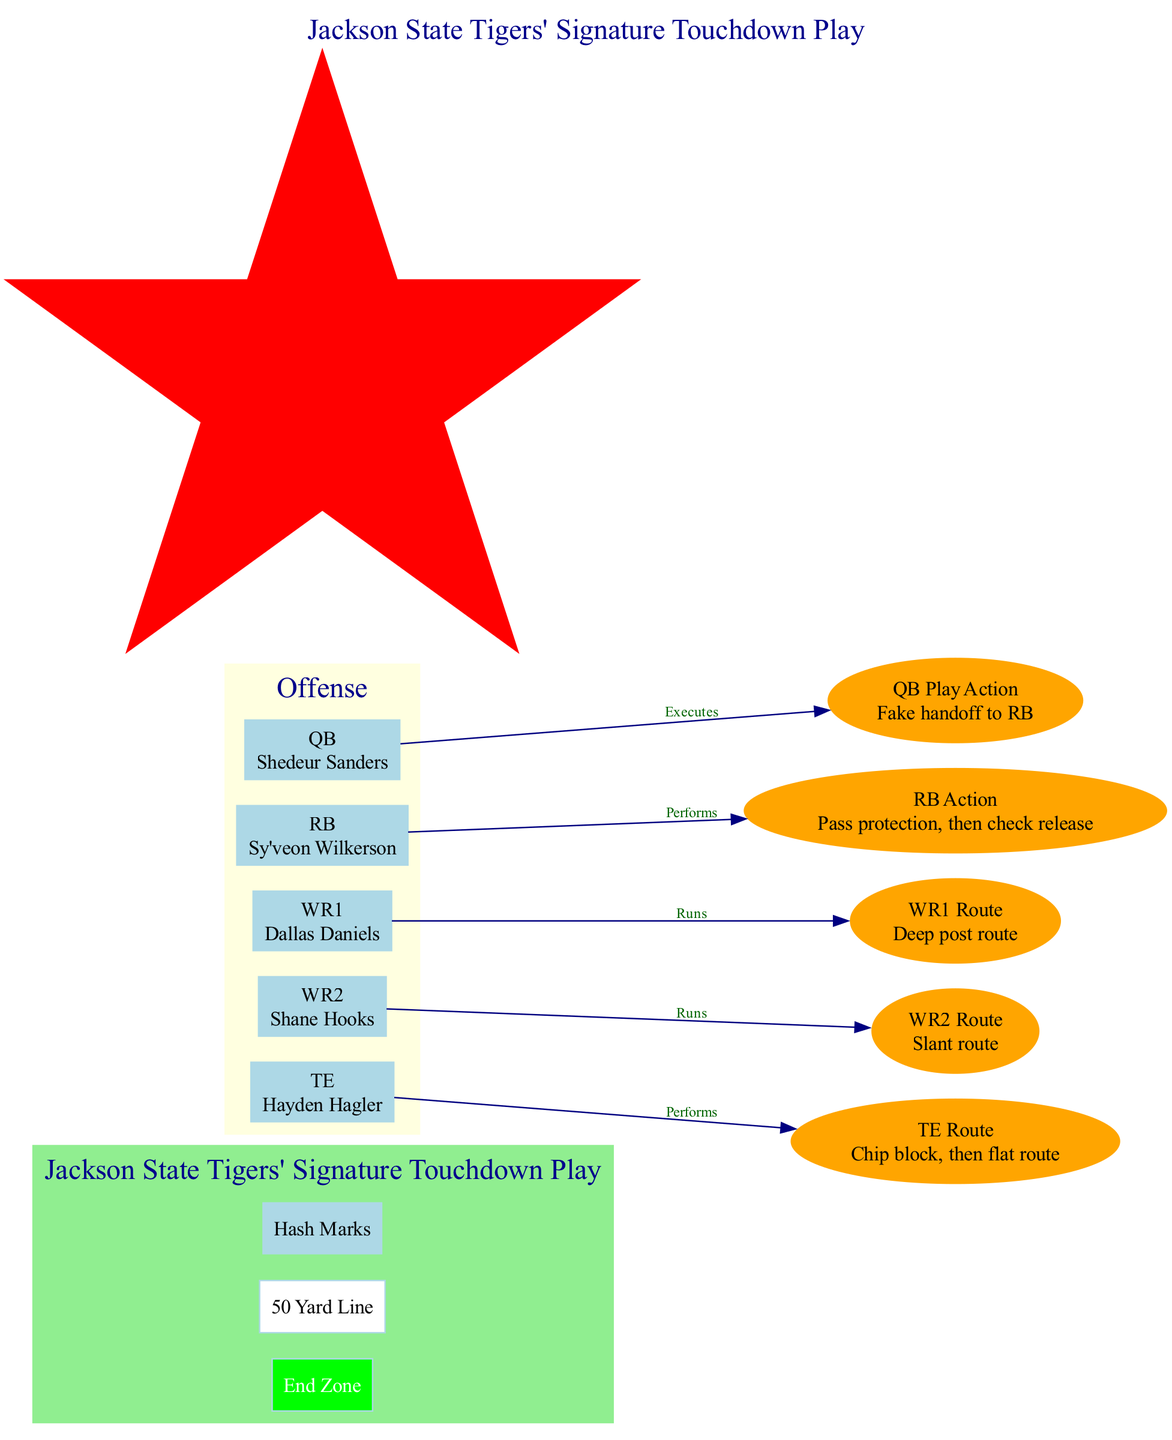What is the position of Shedeur Sanders? In the offensive section of the diagram, there is a label for the player at position 'QB', which indicates that Shedeur Sanders plays as the quarterback.
Answer: QB How many offensive players are listed? Counting the nodes within the offensive subgraph, there are five players represented: QB, RB, WR1, WR2, and TE.
Answer: 5 What route does WR1 run? The diagram shows that WR1 (Dallas Daniels) runs a 'Deep post route' as indicated in the actions connected to that node.
Answer: Deep post route What action does the RB perform? The node associated with RB (Sy'veon Wilkerson) indicates that the action performed is 'Pass protection, then check release' according to the diagram’s descriptions.
Answer: Pass protection, then check release Who performs a chip block before running a route? The diagram indicates that the Tight End (TE) acts by performing a 'Chip block, then flat route', hence it is the TE (Hayden Hagler).
Answer: Hayden Hagler How many action components are there? By enumerating the different actions listed in the play components, we find that there are five distinct actions outlined in the diagram.
Answer: 5 Which action is executed by the QB? The diagram connects the QB (Shedeur Sanders) to the action labeled 'QB Play Action', indicating that this is the action executed by the quarterback.
Answer: QB Play Action What is the key concept of this offensive play? The key concept node in the diagram specifies 'SWAC-style spread offense', highlighting the overarching strategy employed in this play.
Answer: SWAC-style spread offense What route does WR2 run? The diagram depicts that WR2 (Shane Hooks) runs a 'Slant route', which is clearly labeled in the list of actions for the play.
Answer: Slant route 